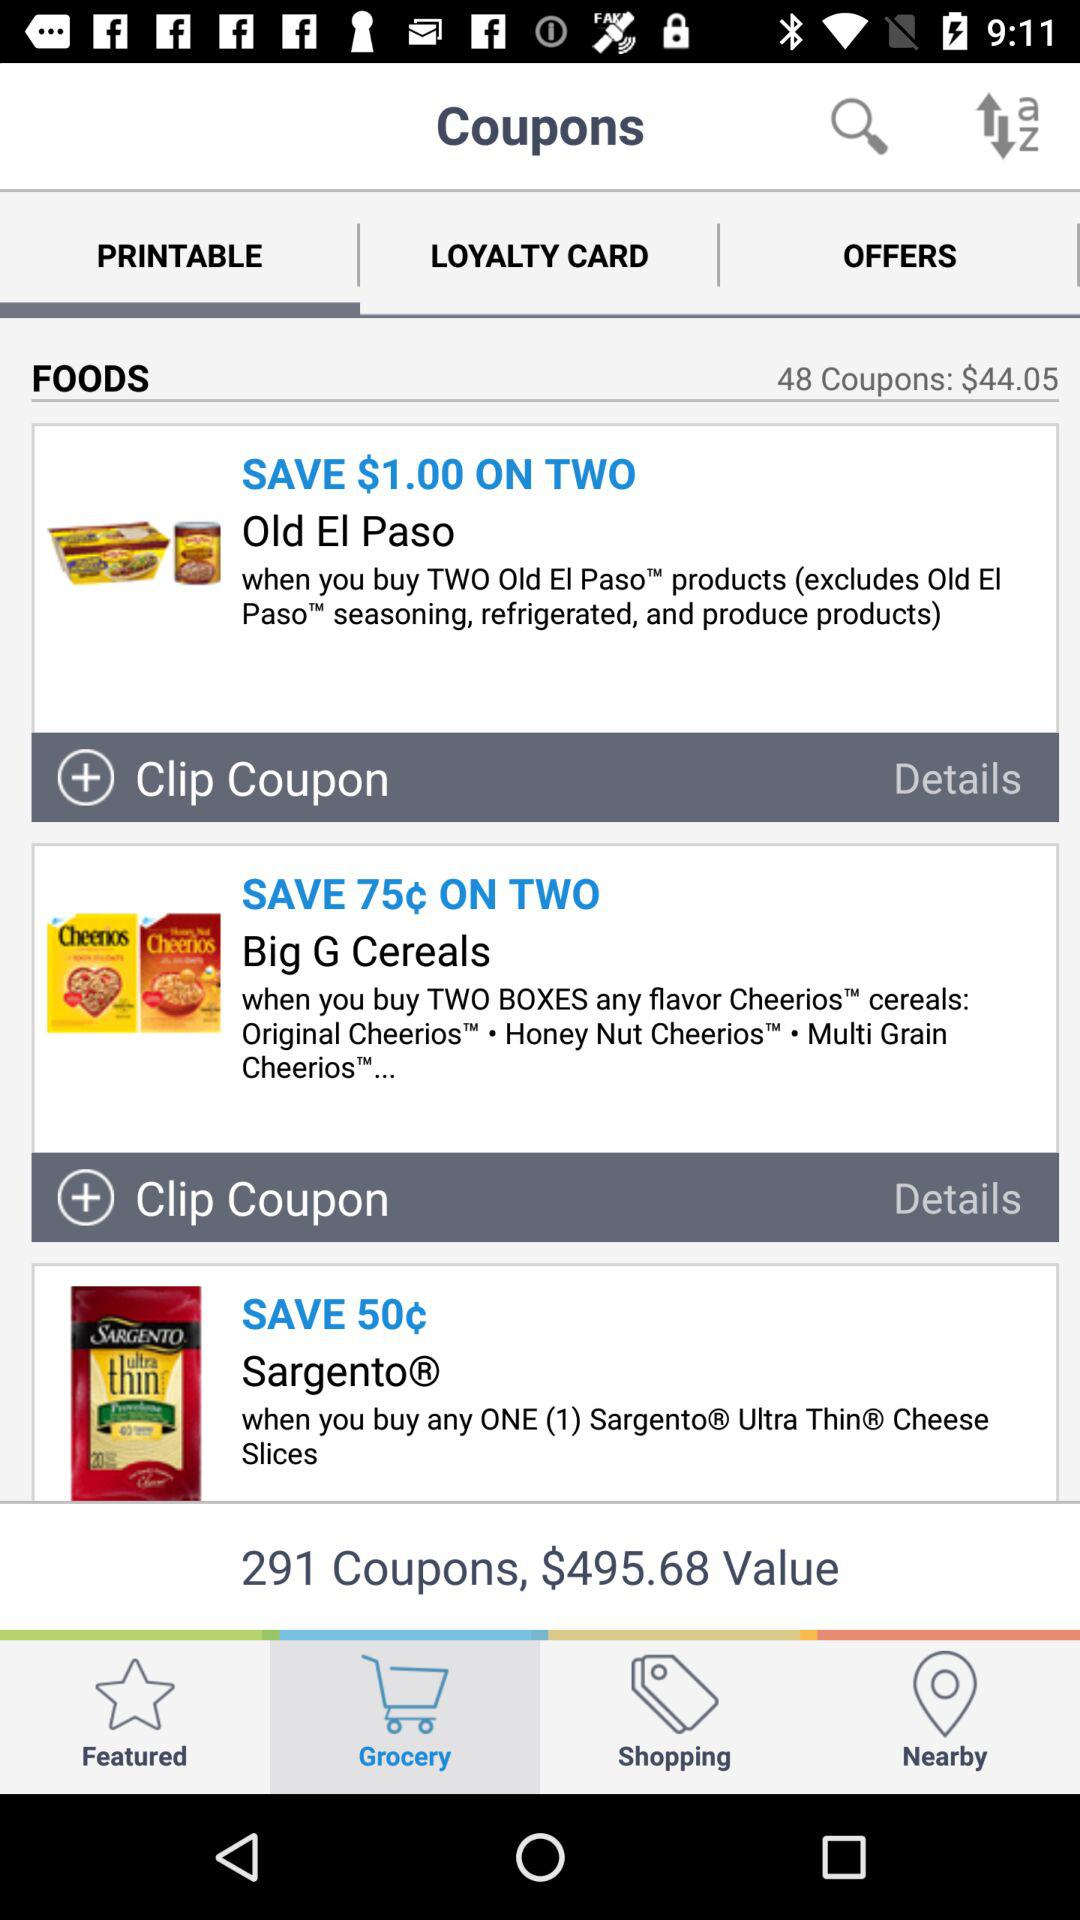How many coupons are available for Sargento® Ultra ThinR Cheese Slices?
Answer the question using a single word or phrase. 1 